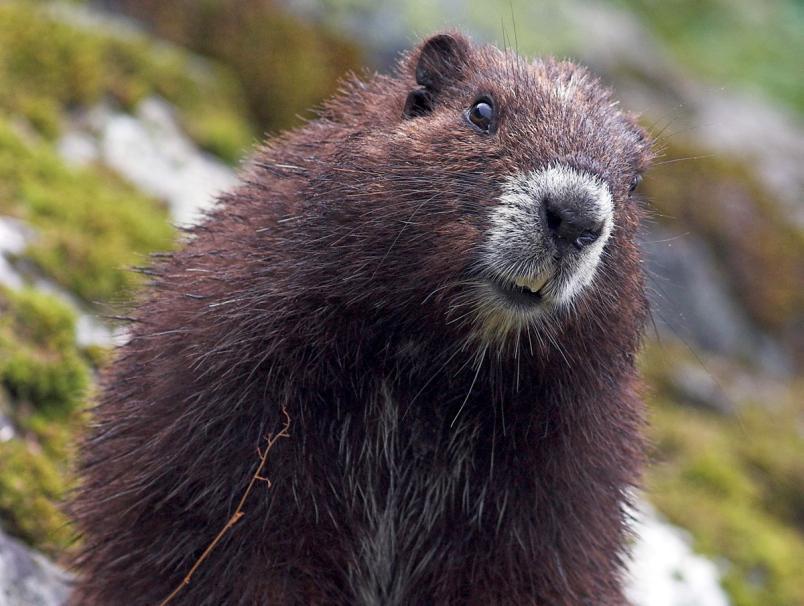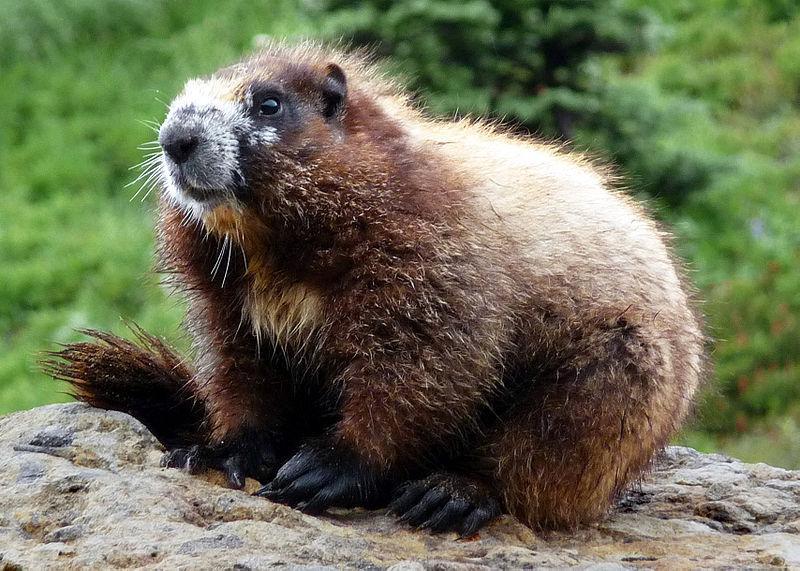The first image is the image on the left, the second image is the image on the right. Evaluate the accuracy of this statement regarding the images: "One of the gophers has a long white underbelly and the gopher that is sitting on a rock or mossy log, does not.". Is it true? Answer yes or no. No. The first image is the image on the left, the second image is the image on the right. Analyze the images presented: Is the assertion "the animal is standing up on the left pic" valid? Answer yes or no. No. 